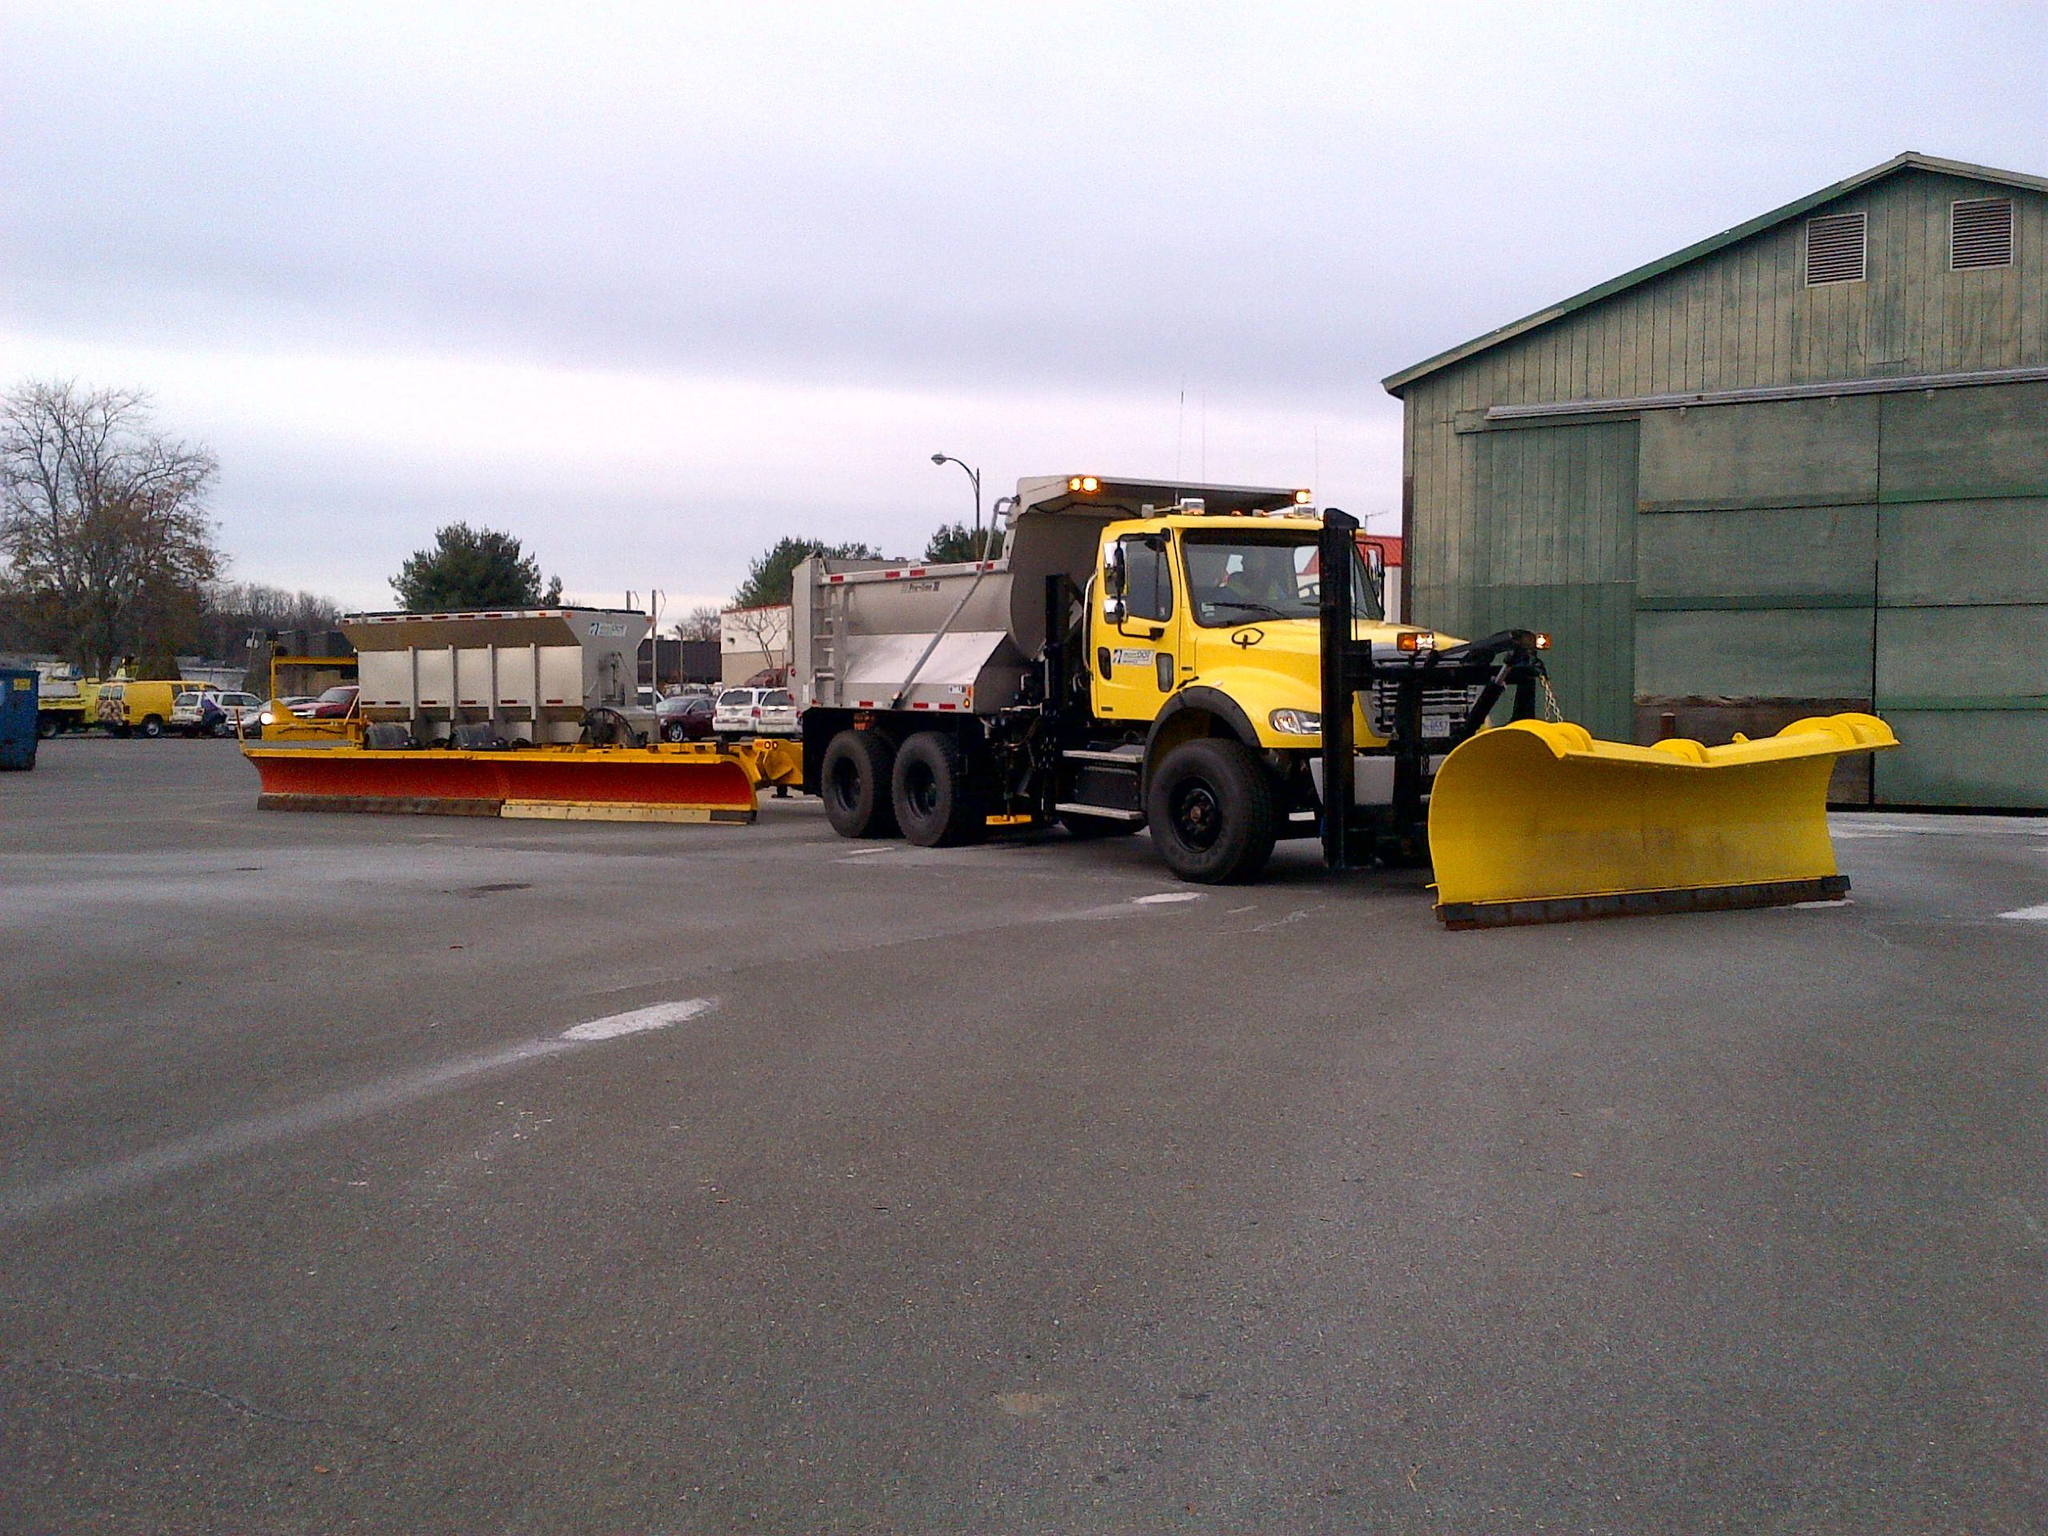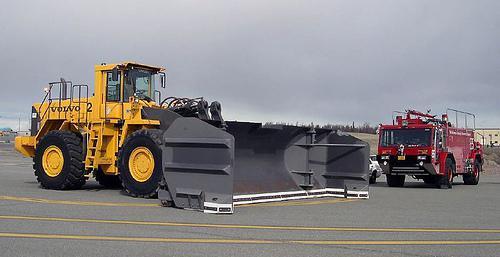The first image is the image on the left, the second image is the image on the right. Considering the images on both sides, is "The plow on the tractor on the right side is grey." valid? Answer yes or no. Yes. The first image is the image on the left, the second image is the image on the right. Assess this claim about the two images: "The equipment in both images is yellow, but one is parked on a snowy surface, while the other is not.". Correct or not? Answer yes or no. No. 